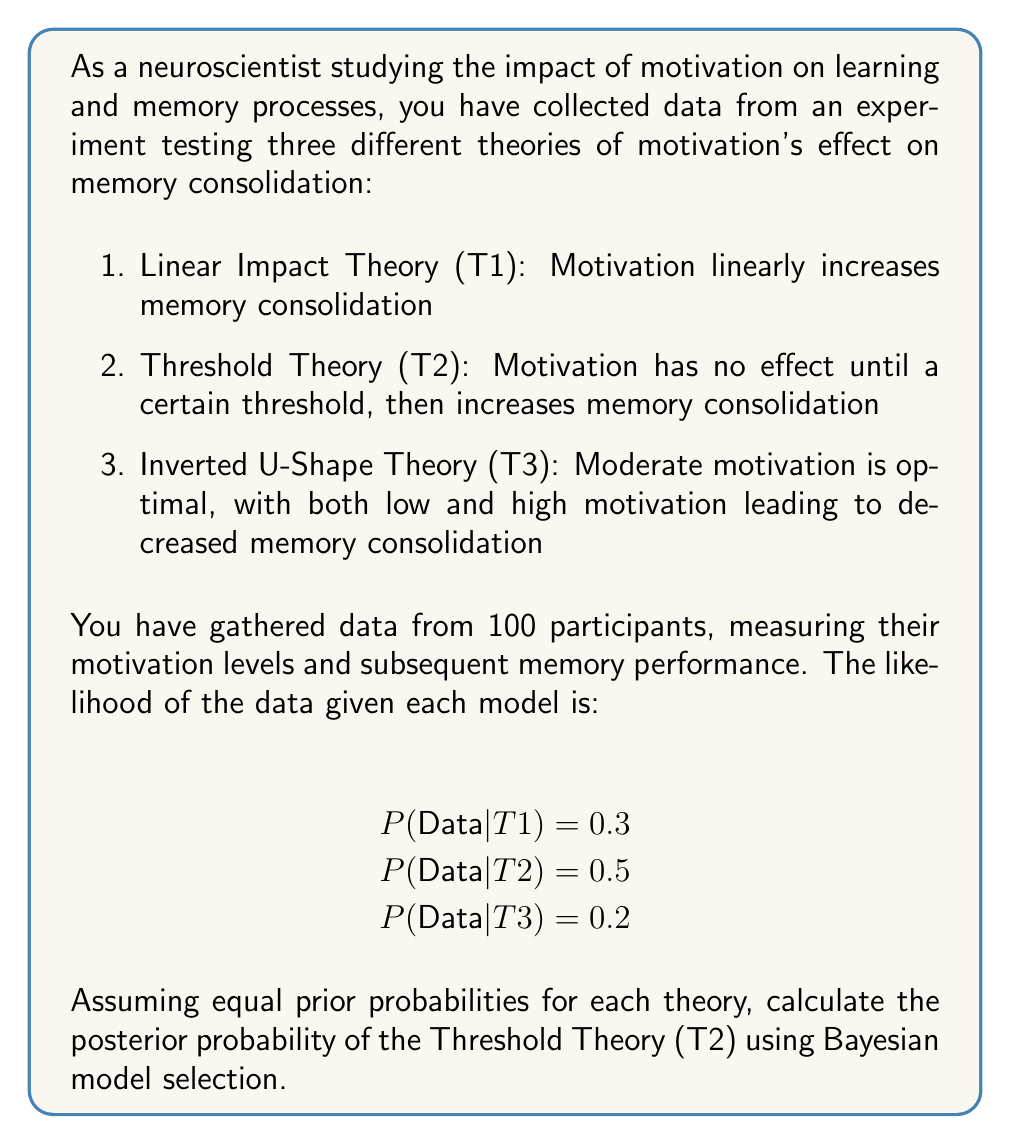Can you solve this math problem? To calculate the posterior probability of the Threshold Theory (T2) using Bayesian model selection, we'll follow these steps:

1. Define the prior probabilities:
   Since we assume equal prior probabilities for each theory:
   $$P(T1) = P(T2) = P(T3) = \frac{1}{3}$$

2. Calculate the marginal likelihood (evidence):
   $$P(Data) = P(Data|T1)P(T1) + P(Data|T2)P(T2) + P(Data|T3)P(T3)$$
   $$P(Data) = 0.3 \cdot \frac{1}{3} + 0.5 \cdot \frac{1}{3} + 0.2 \cdot \frac{1}{3}$$
   $$P(Data) = 0.1 + 0.1667 + 0.0667 = 0.3334$$

3. Apply Bayes' theorem to calculate the posterior probability of T2:
   $$P(T2|Data) = \frac{P(Data|T2)P(T2)}{P(Data)}$$
   $$P(T2|Data) = \frac{0.5 \cdot \frac{1}{3}}{0.3334}$$
   $$P(T2|Data) = \frac{0.1667}{0.3334} = 0.5$$

Therefore, the posterior probability of the Threshold Theory (T2) is 0.5 or 50%.
Answer: 0.5 